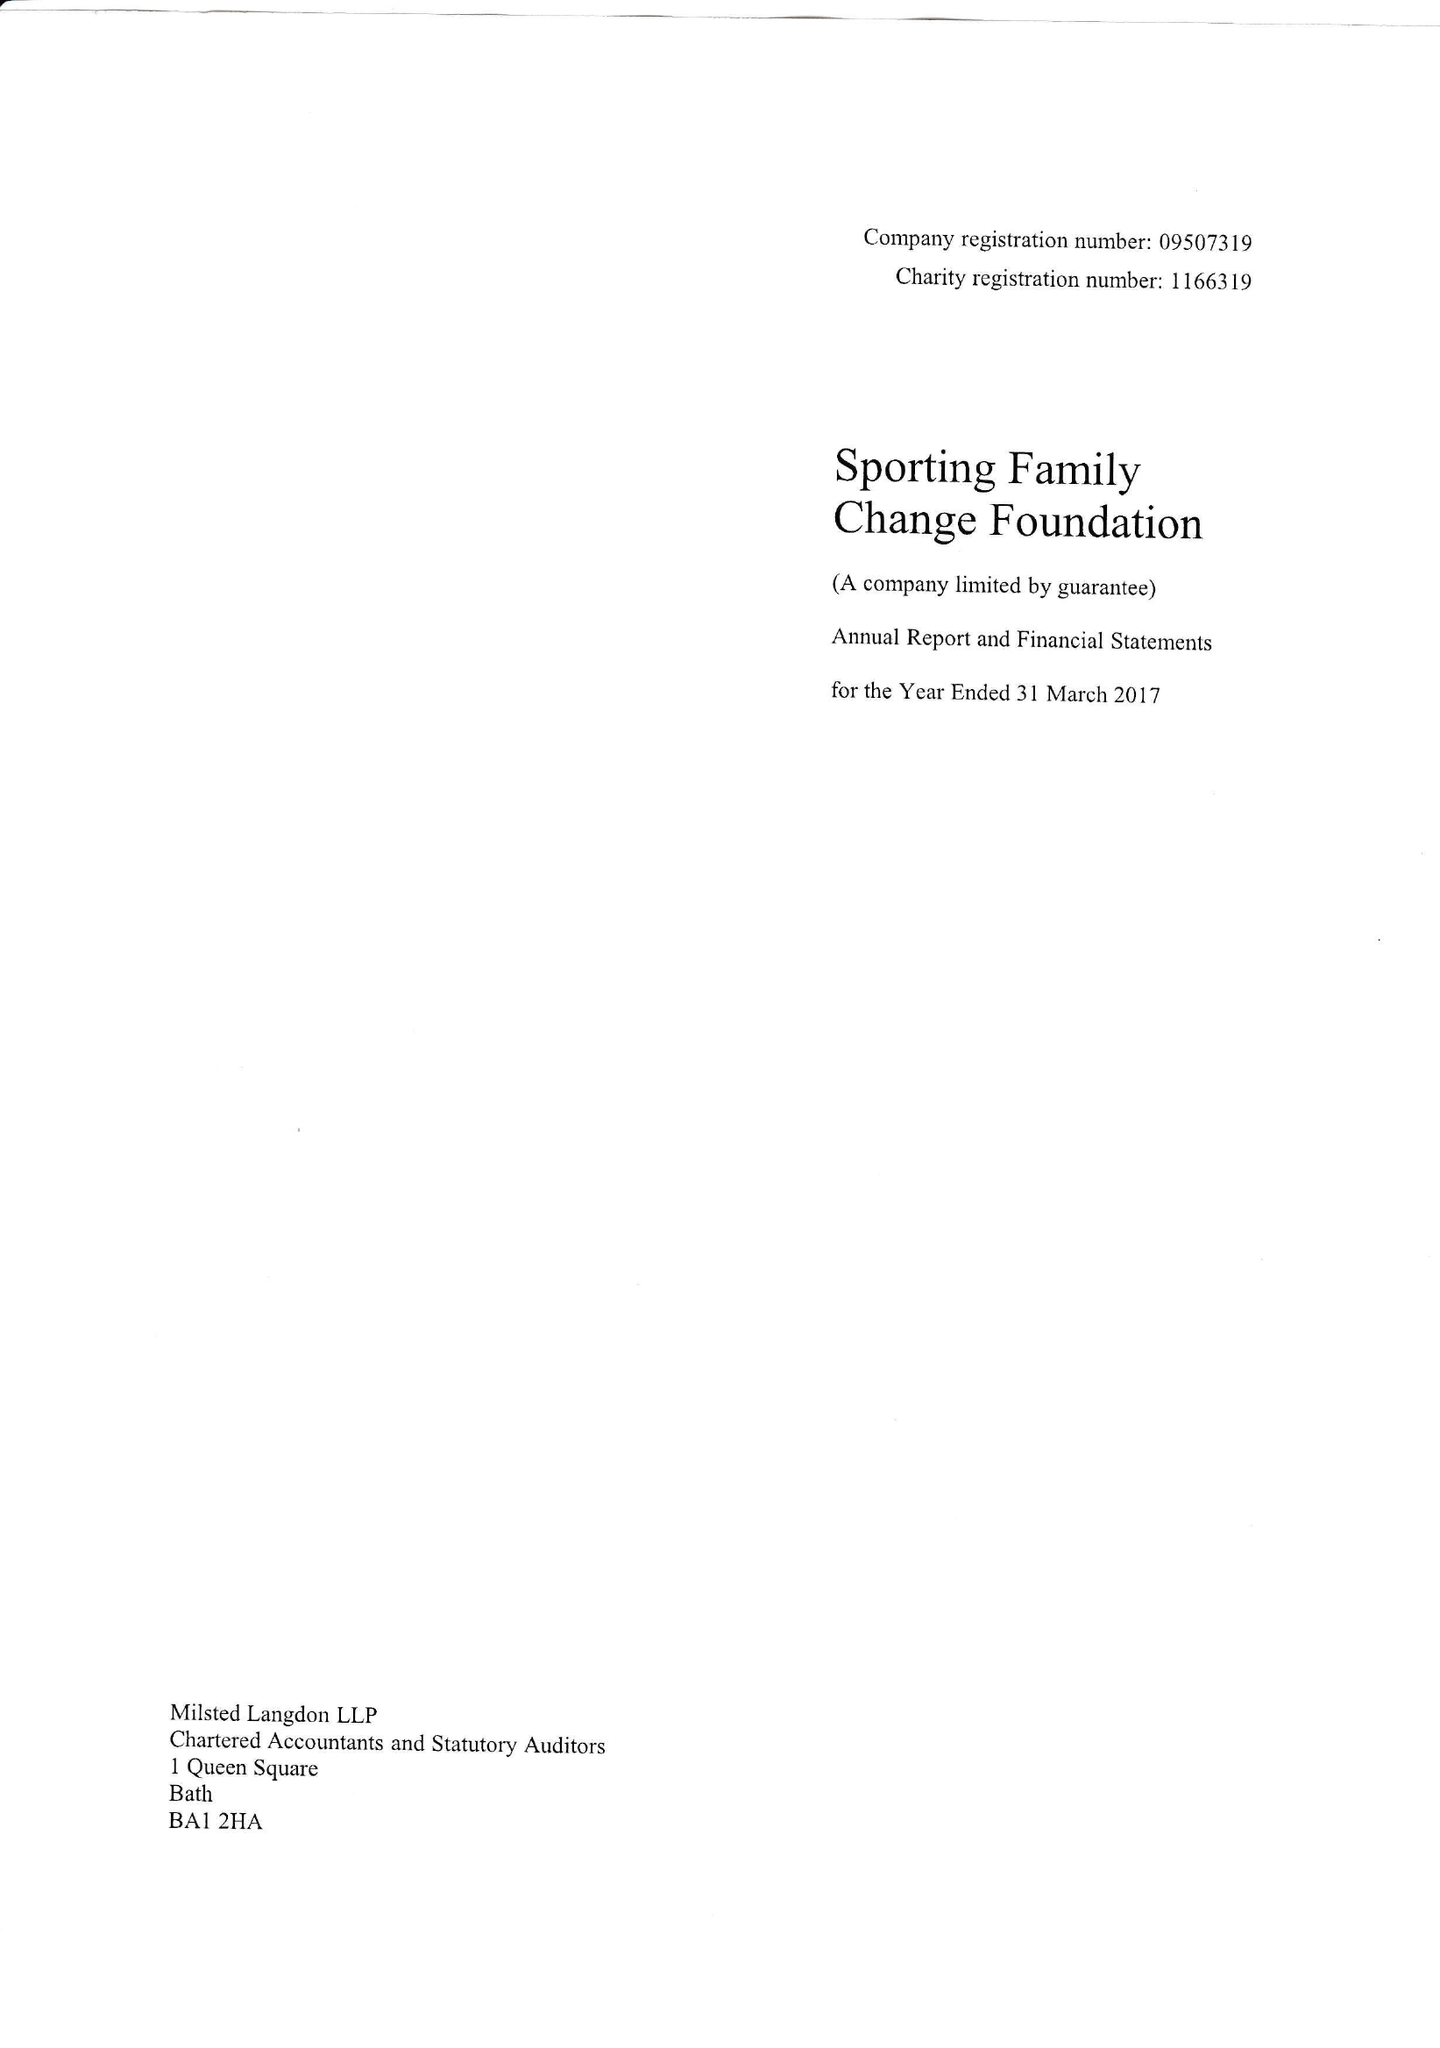What is the value for the report_date?
Answer the question using a single word or phrase. 2017-04-01 